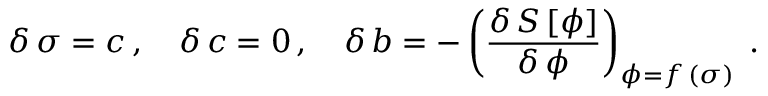Convert formula to latex. <formula><loc_0><loc_0><loc_500><loc_500>\delta \, \sigma = c \, , \quad \delta \, c = 0 \, , \quad \delta \, b = - \left ( \frac { \delta \, S \, [ \phi ] } { \delta \, \phi } \right ) _ { \phi = f \, ( \sigma ) } \, .</formula> 